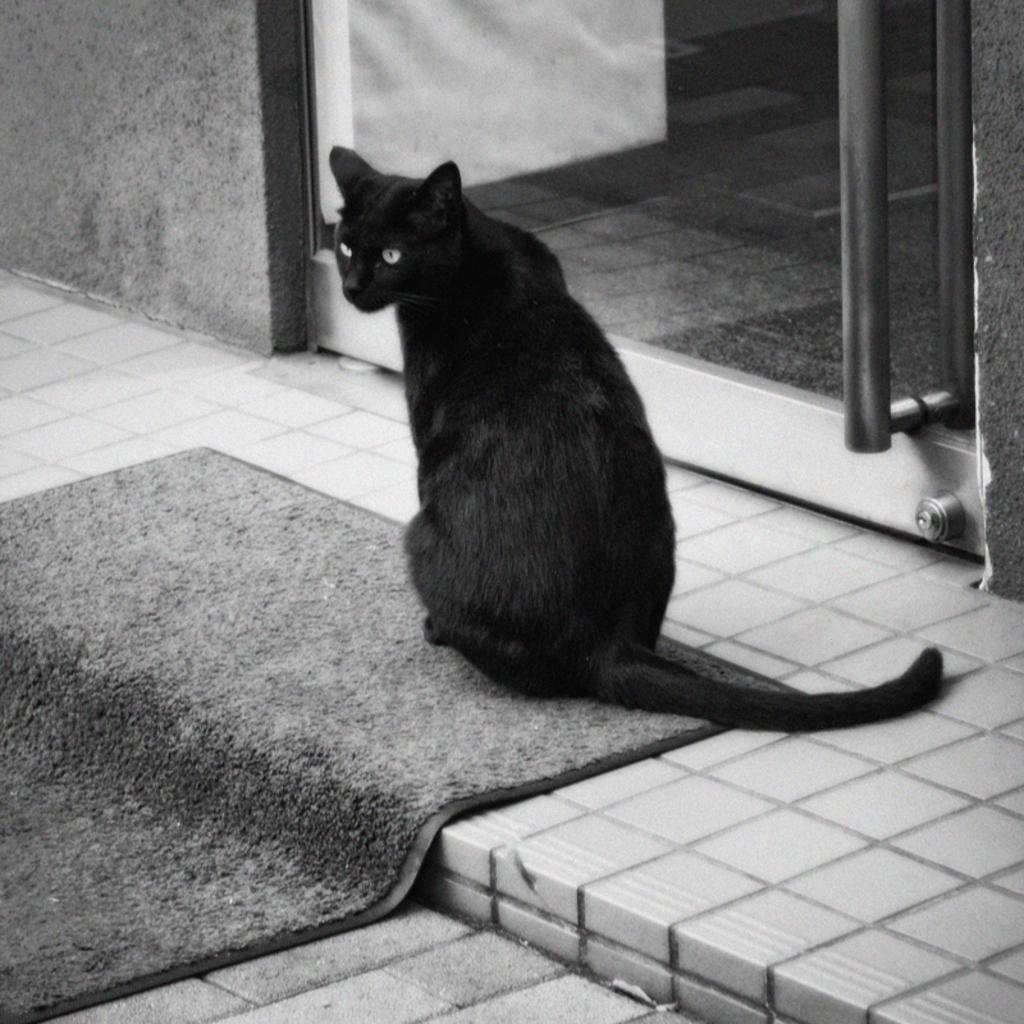What is the color scheme of the image? The image is black and white. What type of animal is present in the image? There is a black color cat in the image. Where is the cat located in the image? The cat is on a mat. What is the mat placed on? The mat is placed on a surface. What can be seen in the background of the image? There is a glass door in the background of the image. What shape is the bone that the cat is chewing on in the image? There is no bone present in the image; it only features a black color cat on a mat. 